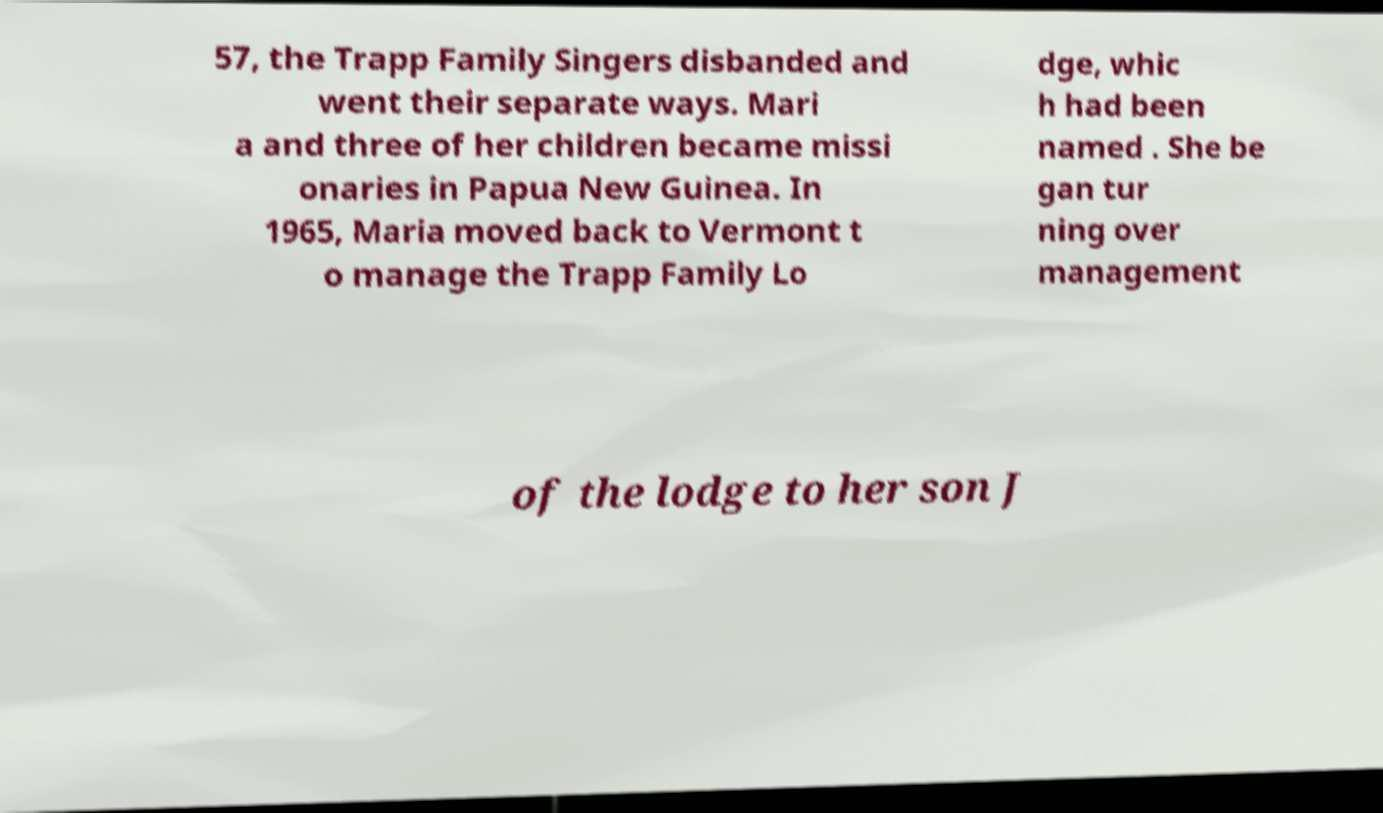Can you accurately transcribe the text from the provided image for me? 57, the Trapp Family Singers disbanded and went their separate ways. Mari a and three of her children became missi onaries in Papua New Guinea. In 1965, Maria moved back to Vermont t o manage the Trapp Family Lo dge, whic h had been named . She be gan tur ning over management of the lodge to her son J 